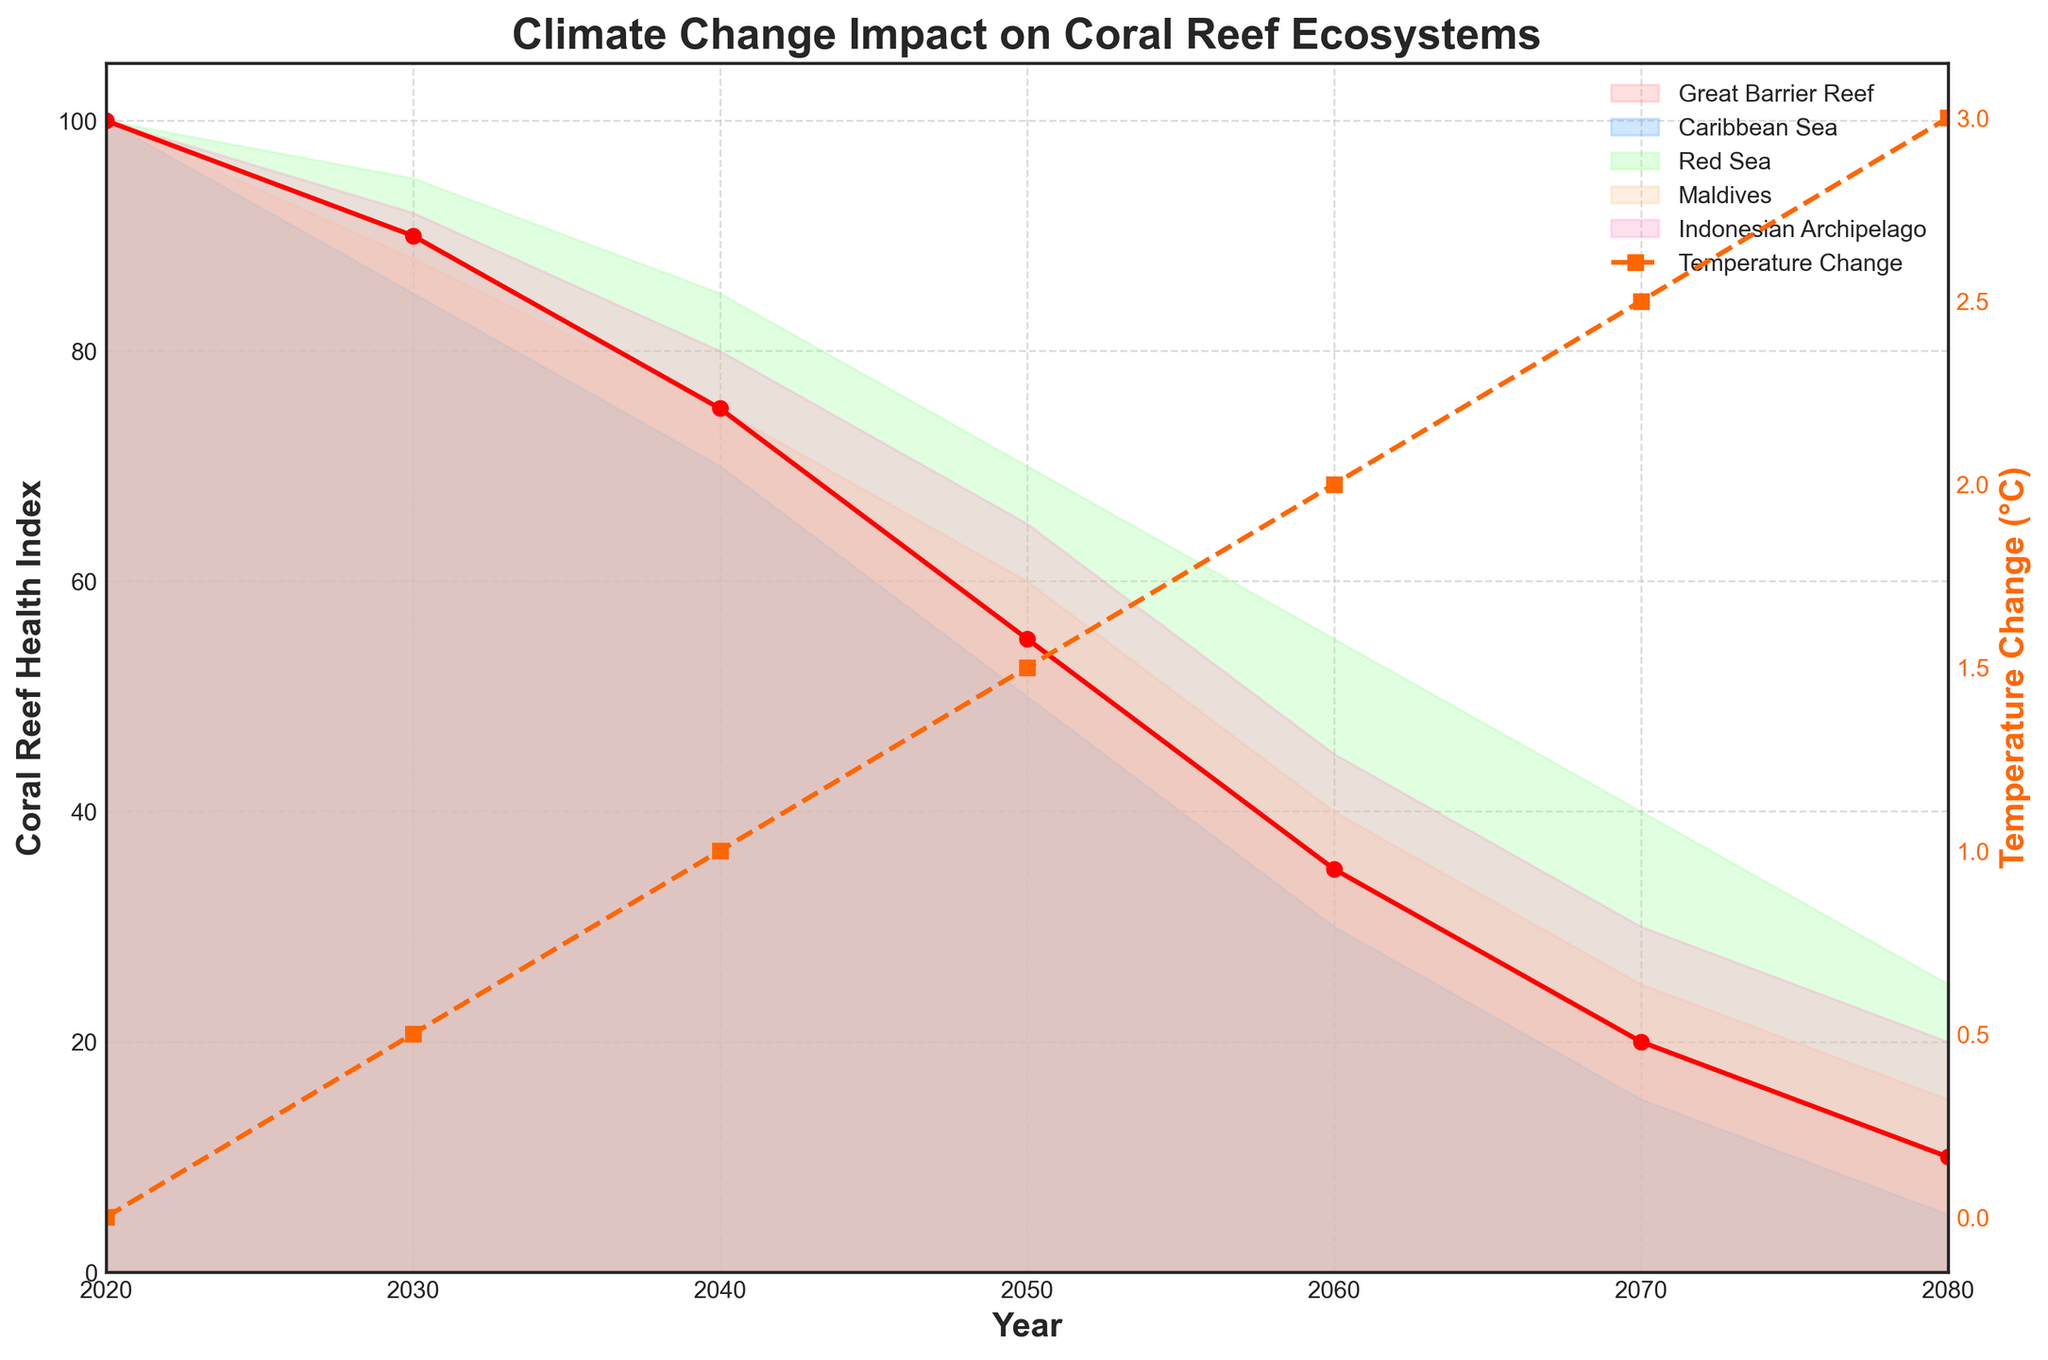What is the temperature change projected in 2050? Based on the figure, we can see that temperature change is one of the plotted lines. By locating the year 2050 on the x-axis and finding where it intersects with the temperature change line, we see the value.
Answer: 1.5°C What is the title of the figure? The title is located at the top center of the figure.
Answer: Climate Change Impact on Coral Reef Ecosystems Which region has the lowest coral reef health index in 2080? By looking at the plotted areas for each region in the year 2080, one can compare the values. The Caribbean Sea’s value is the lowest amongst all.
Answer: Caribbean Sea How much difference is there in the coral reef health index between the Great Barrier Reef and the Caribbean Sea in 2060? By looking at the values for both regions in the year 2060, we can see Great Barrier Reef has an index of 35, and the Caribbean Sea has 30. The difference is calculated by subtracting these two values.
Answer: 5 What is the relationship between temperature change and the coral reef health index over the years? One can observe the figure to see that as the temperature change increases (represented by the dashed line), the coral reef health index decreases for all regions (represented by the shaded areas). This indicates a negative correlation between temperature change and coral reef health.
Answer: Negative correlation In which year does the Great Barrier Reef health index drop to half of its initial value in 2020? The initial value in 2020 is 100. We look for the year in which the Great Barrier Reef's index drops to 50. This value appears in the year 2050.
Answer: 2050 Which region's coral reef health index deteriorates the fastest between 2020 and 2040? We observe the changes in health indices between 2020 and 2040 for each region. The Caribbean Sea drops from 100 to 70, which is the steepest decline among all regions.
Answer: Caribbean Sea What is the difference in temperature change between 2030 and 2070? The temperature change in 2030 is 0.5°C and in 2070 is 2.5°C. The difference is calculated as 2.5 - 0.5.
Answer: 2.0°C 